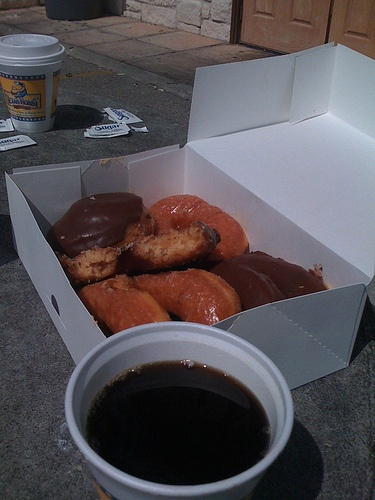Describe the objects in this image and their specific colors. I can see cup in gray and black tones, donut in gray, black, maroon, and brown tones, cup in gray and black tones, donut in gray, maroon, brown, and black tones, and donut in gray, maroon, brown, and black tones in this image. 